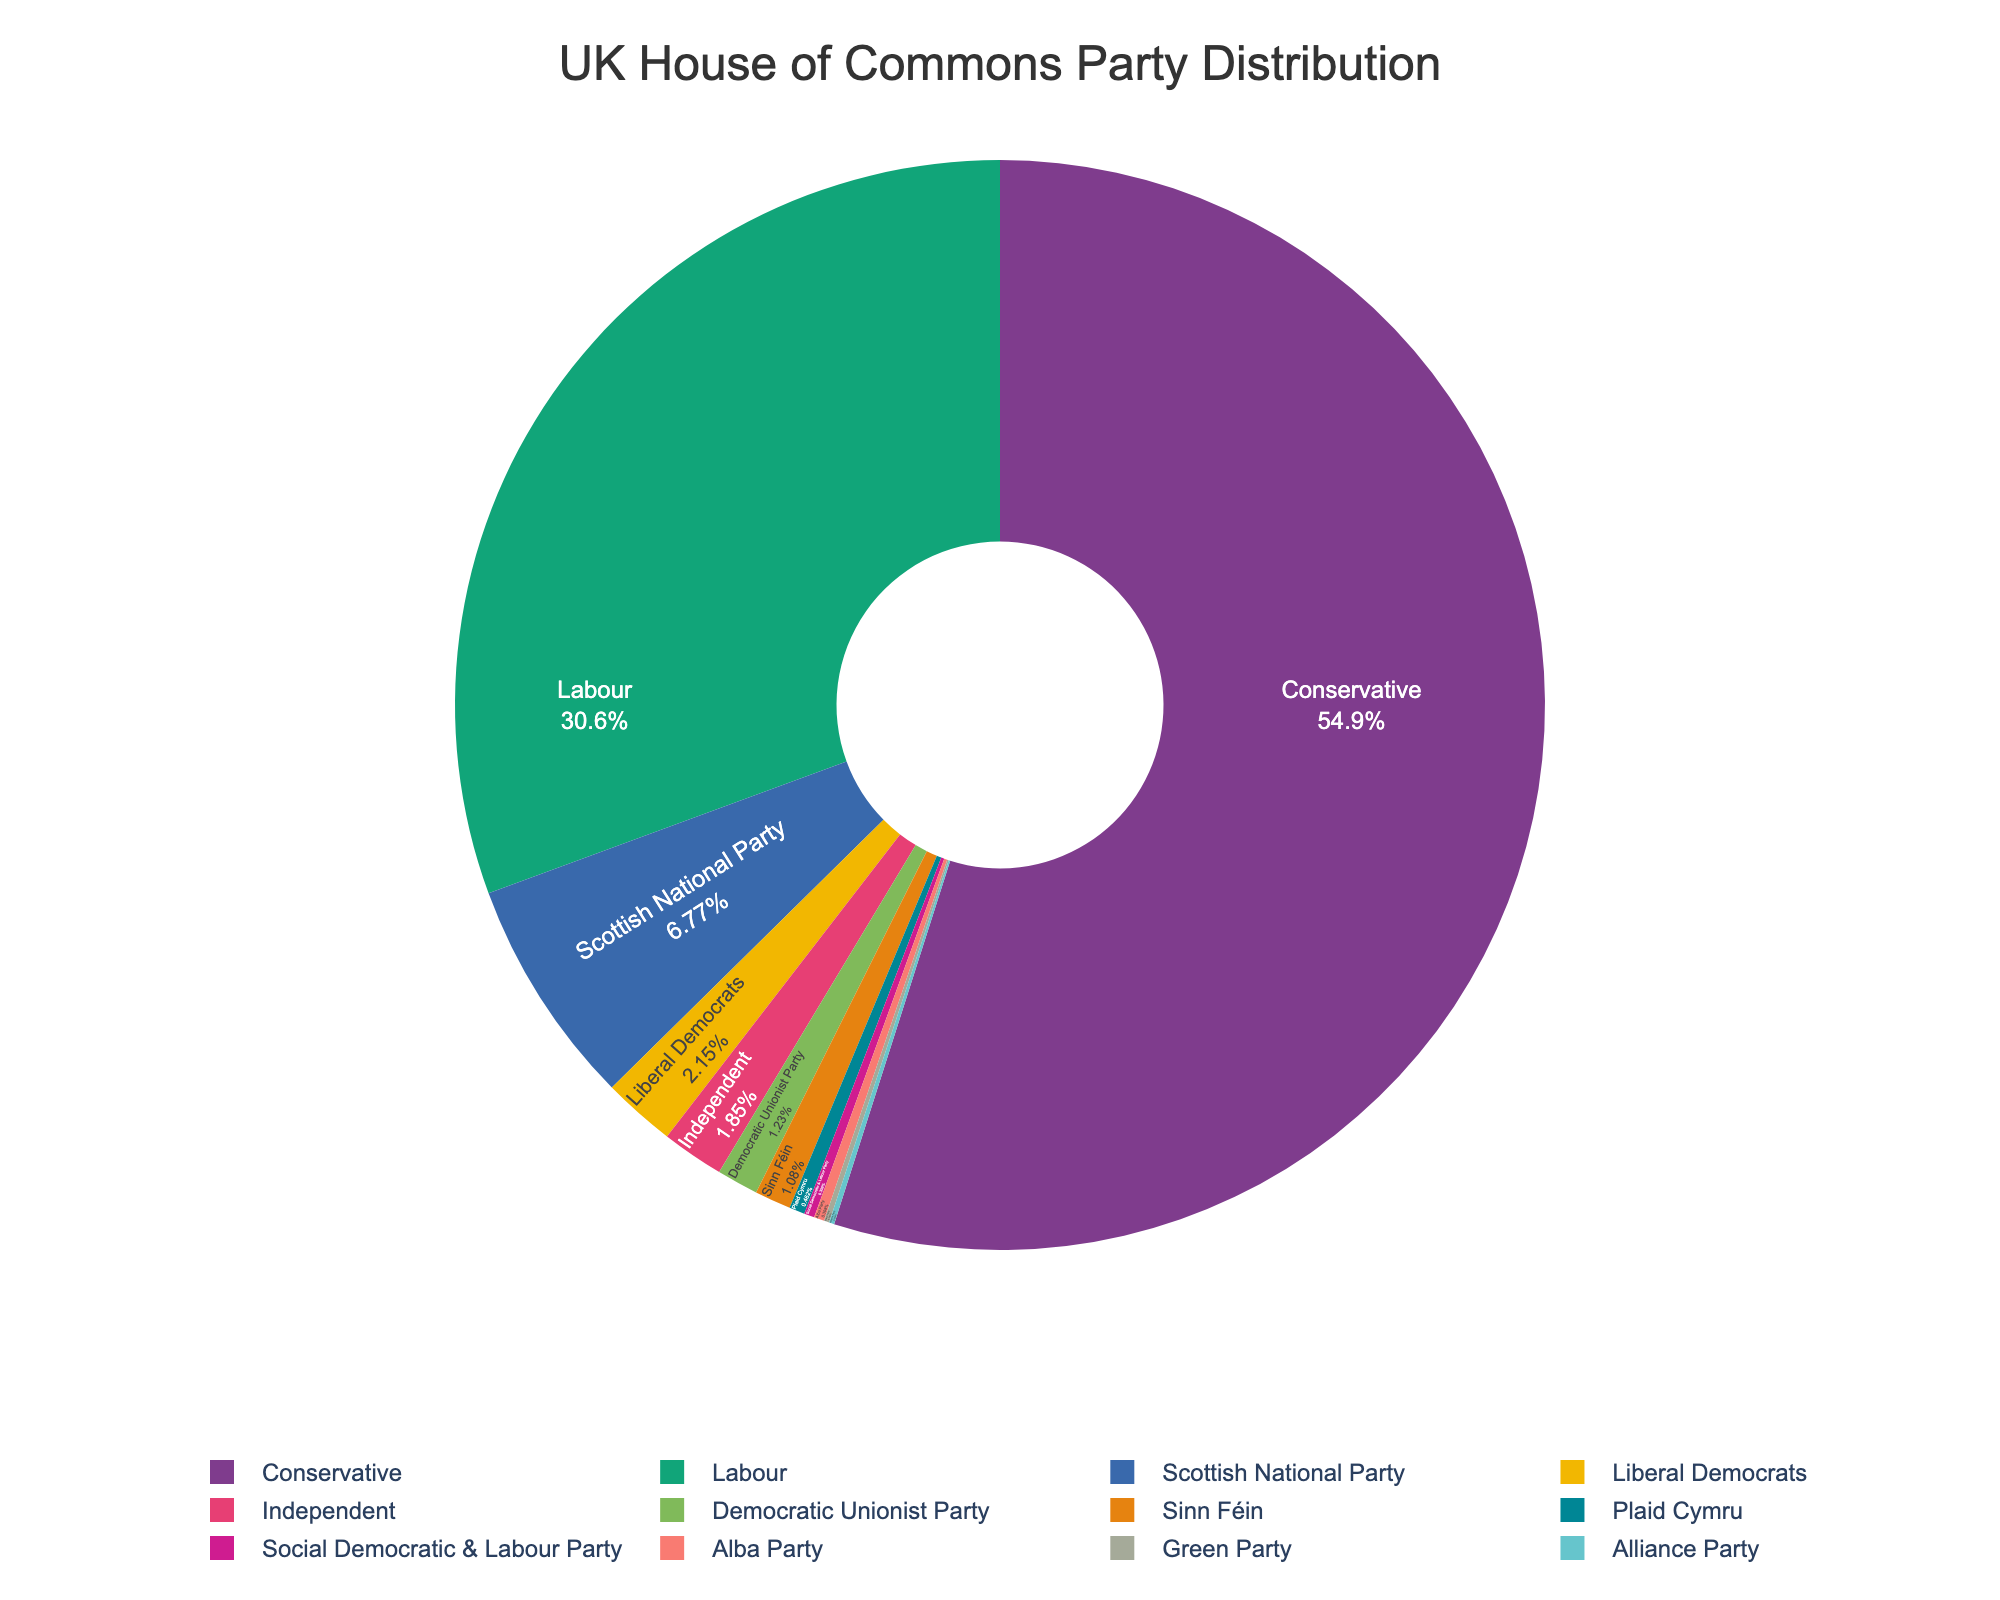What percentage of seats is held by the Conservative Party? The pie chart shows the percentage of seats held by each party. Look for the segment labeled "Conservative" and read the percentage value.
Answer: Approximately 55.9% How many total seats do the Scottish National Party and Liberal Democrats hold together? Add the seats of the Scottish National Party (44) and the Liberal Democrats (14). 44 + 14 = 58.
Answer: 58 Which party holds the smallest number of seats, and how many do they hold? Identify the segment with the smallest proportion in the pie chart, which is labeled as the Green Party or Alliance Party, each holding 1 seat.
Answer: Green Party or Alliance Party, 1 seat Which party holds more seats: Sinn Féin or the Democratic Unionist Party, and by how many seats? Compare the seat numbers of Sinn Féin (7) and the Democratic Unionist Party (8). The Democratic Unionist Party holds 1 more seat than Sinn Féin.
Answer: Democratic Unionist Party, by 1 seat What are the colors representing the Labour Party and the Conservative Party? Look at the segments labeled "Labour" and "Conservative" in the pie chart and note the colors used.
Answer: Labour: Red, Conservative: Blue How many seats in total are held by independent members? Look for the segment labeled “Independent” in the pie chart and note the number of seats, which is 12.
Answer: 12 What is the combined percentage of seats held by smaller parties (those not Conservative or Labour)? Add the percentages of all parties except Conservative and Labour.
Answer: Approximately 31.9% How does the seat distribution between the Green Party and Plaid Cymru compare? Identify and compare the segments for Green Party (1 seat) and Plaid Cymru (3 seats). Plaid Cymru holds more seats.
Answer: Plaid Cymru holds more seats If the number of seats held by Labour increased by 50%, how many additional seats would they have? Calculate 50% of Labour's current seats (199). 199 * 0.50 = 99.5, so they would gain 100 seats.
Answer: 100 If the seats of the Liberal Democrats and Independent members are combined, will it be more than the Scottish National Party? Add seats of Liberal Democrats (14) and Independent (12), then compare the sum (26) with the Scottish National Party (44). The combined total is less.
Answer: No, it will not 